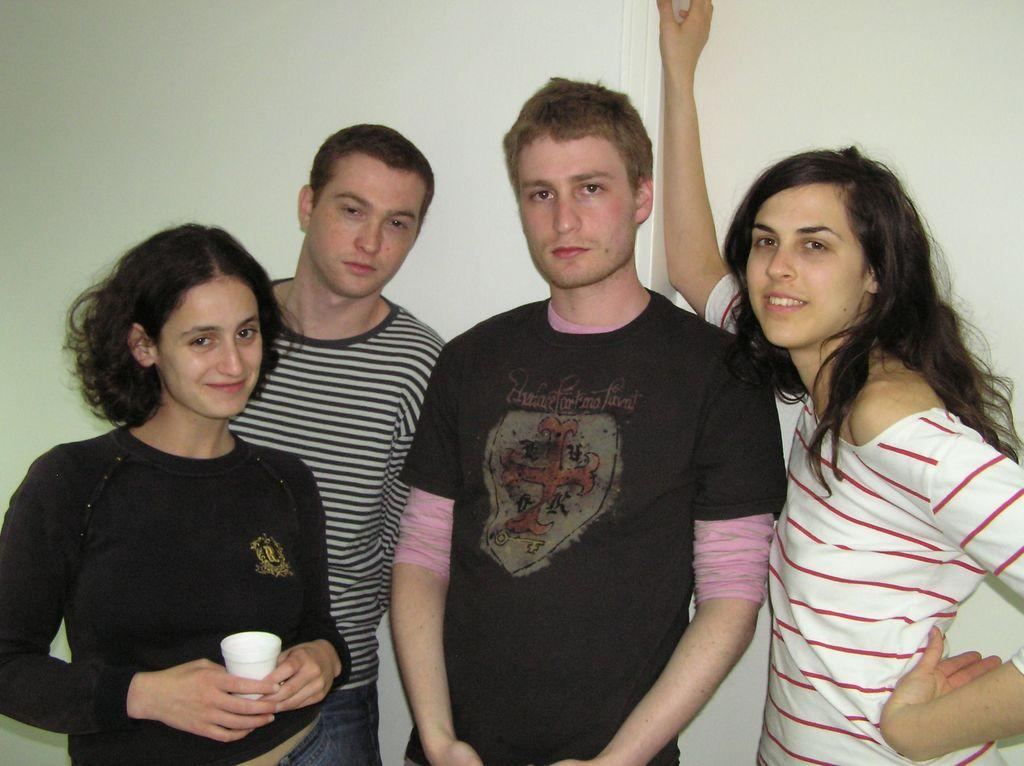How many people are present in the image? There are two people standing in the image. What is the expression of the first woman in the image? The first woman is standing and smiling. What is the second woman holding in the image? The second woman is standing, smiling, and holding a cup. What can be seen in the background of the image? There is a wall in the background of the image. What is the educational background of the hot limit in the image? There is no hot limit present in the image, so it is not possible to determine its educational background. 